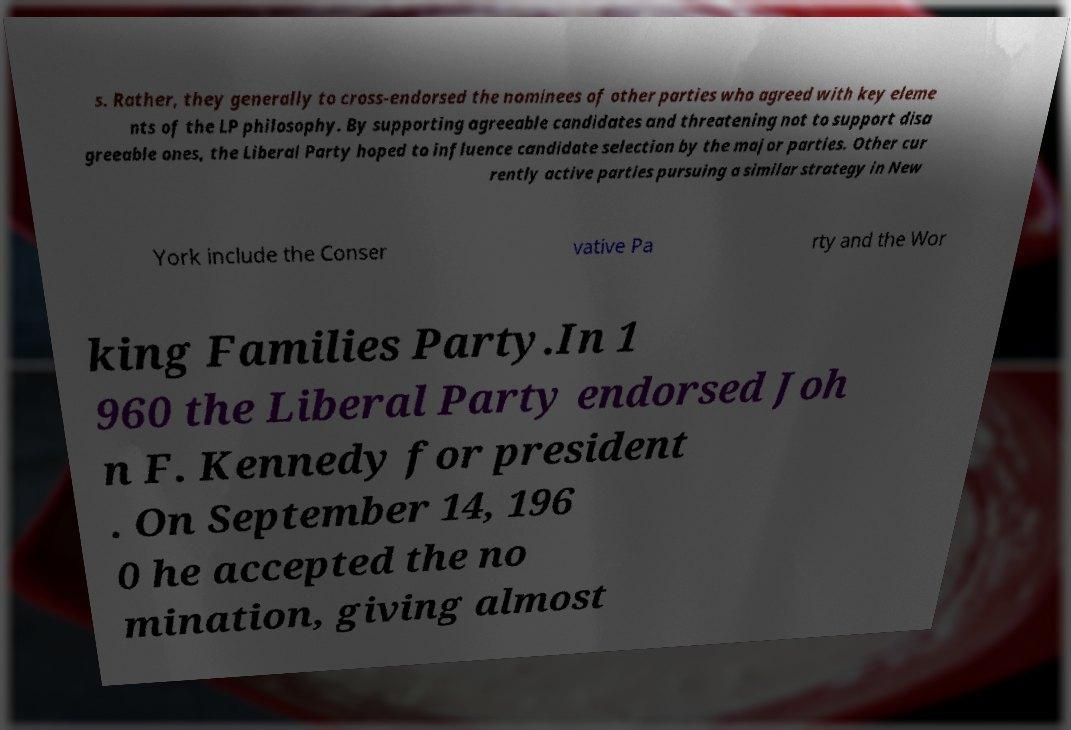Could you extract and type out the text from this image? s. Rather, they generally to cross-endorsed the nominees of other parties who agreed with key eleme nts of the LP philosophy. By supporting agreeable candidates and threatening not to support disa greeable ones, the Liberal Party hoped to influence candidate selection by the major parties. Other cur rently active parties pursuing a similar strategy in New York include the Conser vative Pa rty and the Wor king Families Party.In 1 960 the Liberal Party endorsed Joh n F. Kennedy for president . On September 14, 196 0 he accepted the no mination, giving almost 